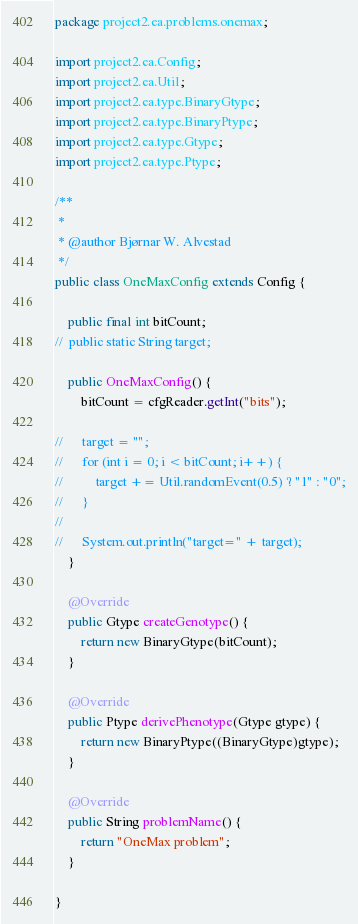<code> <loc_0><loc_0><loc_500><loc_500><_Java_>package project2.ea.problems.onemax;

import project2.ea.Config;
import project2.ea.Util;
import project2.ea.type.BinaryGtype;
import project2.ea.type.BinaryPtype;
import project2.ea.type.Gtype;
import project2.ea.type.Ptype;

/**
 *
 * @author Bjørnar W. Alvestad
 */
public class OneMaxConfig extends Config {
	
	public final int bitCount;
//	public static String target;
	
	public OneMaxConfig() {
		bitCount = cfgReader.getInt("bits");
		
//		target = "";
//		for (int i = 0; i < bitCount; i++) {
//			target += Util.randomEvent(0.5) ? "1" : "0";
//		}
//		
//		System.out.println("target=" + target);
	}
	
	@Override
	public Gtype createGenotype() {
		return new BinaryGtype(bitCount);
	}

	@Override
	public Ptype derivePhenotype(Gtype gtype) {
		return new BinaryPtype((BinaryGtype)gtype);
	}

	@Override
	public String problemName() {
		return "OneMax problem";
	}
	
}
</code> 